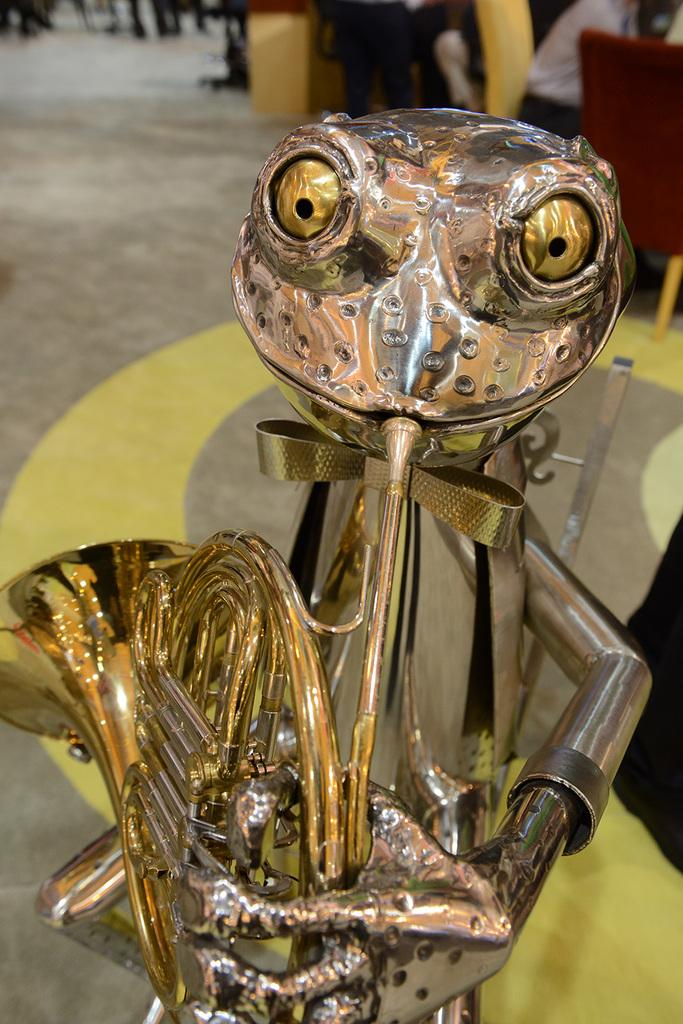What type of toy is visible in the image? There is a metal toy in the image. Can you describe the setting in which the toy is located? In the background of the image, there are people seated on chairs. How many beds can be seen in the image? There are no beds present in the image. 